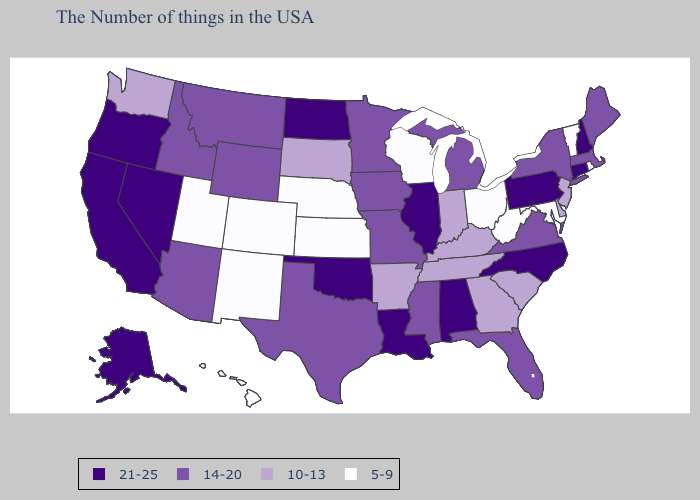What is the value of Delaware?
Concise answer only. 10-13. Does Missouri have the highest value in the USA?
Concise answer only. No. Which states have the lowest value in the West?
Give a very brief answer. Colorado, New Mexico, Utah, Hawaii. Name the states that have a value in the range 21-25?
Short answer required. New Hampshire, Connecticut, Pennsylvania, North Carolina, Alabama, Illinois, Louisiana, Oklahoma, North Dakota, Nevada, California, Oregon, Alaska. Name the states that have a value in the range 14-20?
Quick response, please. Maine, Massachusetts, New York, Virginia, Florida, Michigan, Mississippi, Missouri, Minnesota, Iowa, Texas, Wyoming, Montana, Arizona, Idaho. Name the states that have a value in the range 14-20?
Answer briefly. Maine, Massachusetts, New York, Virginia, Florida, Michigan, Mississippi, Missouri, Minnesota, Iowa, Texas, Wyoming, Montana, Arizona, Idaho. Does the map have missing data?
Concise answer only. No. Does Arizona have the highest value in the West?
Answer briefly. No. Name the states that have a value in the range 21-25?
Quick response, please. New Hampshire, Connecticut, Pennsylvania, North Carolina, Alabama, Illinois, Louisiana, Oklahoma, North Dakota, Nevada, California, Oregon, Alaska. What is the highest value in the USA?
Write a very short answer. 21-25. Among the states that border Utah , which have the highest value?
Concise answer only. Nevada. What is the value of Georgia?
Keep it brief. 10-13. What is the value of Georgia?
Short answer required. 10-13. Which states have the lowest value in the South?
Give a very brief answer. Maryland, West Virginia. 